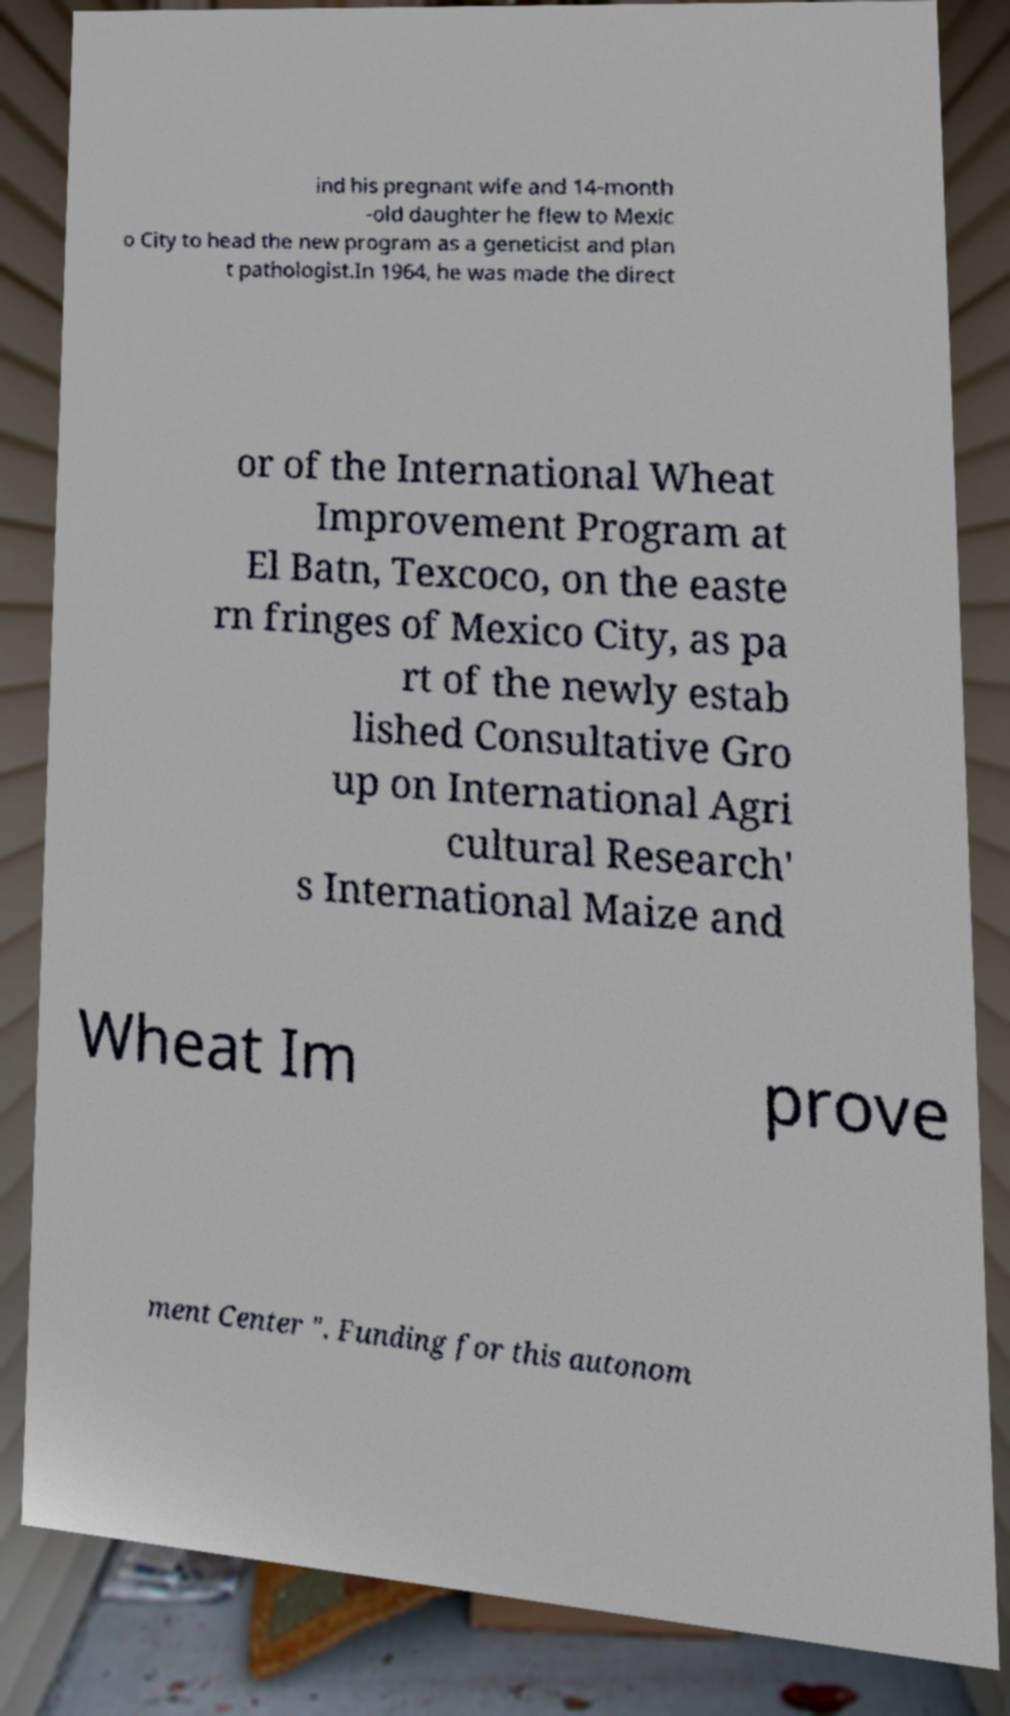Please identify and transcribe the text found in this image. ind his pregnant wife and 14-month -old daughter he flew to Mexic o City to head the new program as a geneticist and plan t pathologist.In 1964, he was made the direct or of the International Wheat Improvement Program at El Batn, Texcoco, on the easte rn fringes of Mexico City, as pa rt of the newly estab lished Consultative Gro up on International Agri cultural Research' s International Maize and Wheat Im prove ment Center ". Funding for this autonom 